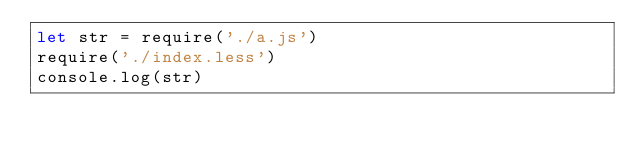<code> <loc_0><loc_0><loc_500><loc_500><_JavaScript_>let str = require('./a.js')
require('./index.less')
console.log(str)</code> 